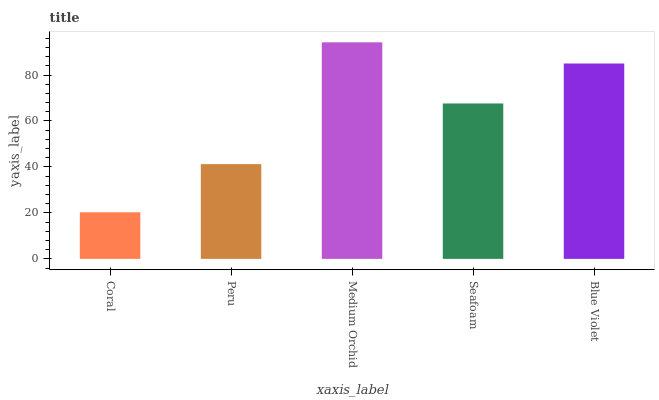Is Coral the minimum?
Answer yes or no. Yes. Is Medium Orchid the maximum?
Answer yes or no. Yes. Is Peru the minimum?
Answer yes or no. No. Is Peru the maximum?
Answer yes or no. No. Is Peru greater than Coral?
Answer yes or no. Yes. Is Coral less than Peru?
Answer yes or no. Yes. Is Coral greater than Peru?
Answer yes or no. No. Is Peru less than Coral?
Answer yes or no. No. Is Seafoam the high median?
Answer yes or no. Yes. Is Seafoam the low median?
Answer yes or no. Yes. Is Coral the high median?
Answer yes or no. No. Is Blue Violet the low median?
Answer yes or no. No. 